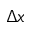<formula> <loc_0><loc_0><loc_500><loc_500>\Delta x</formula> 